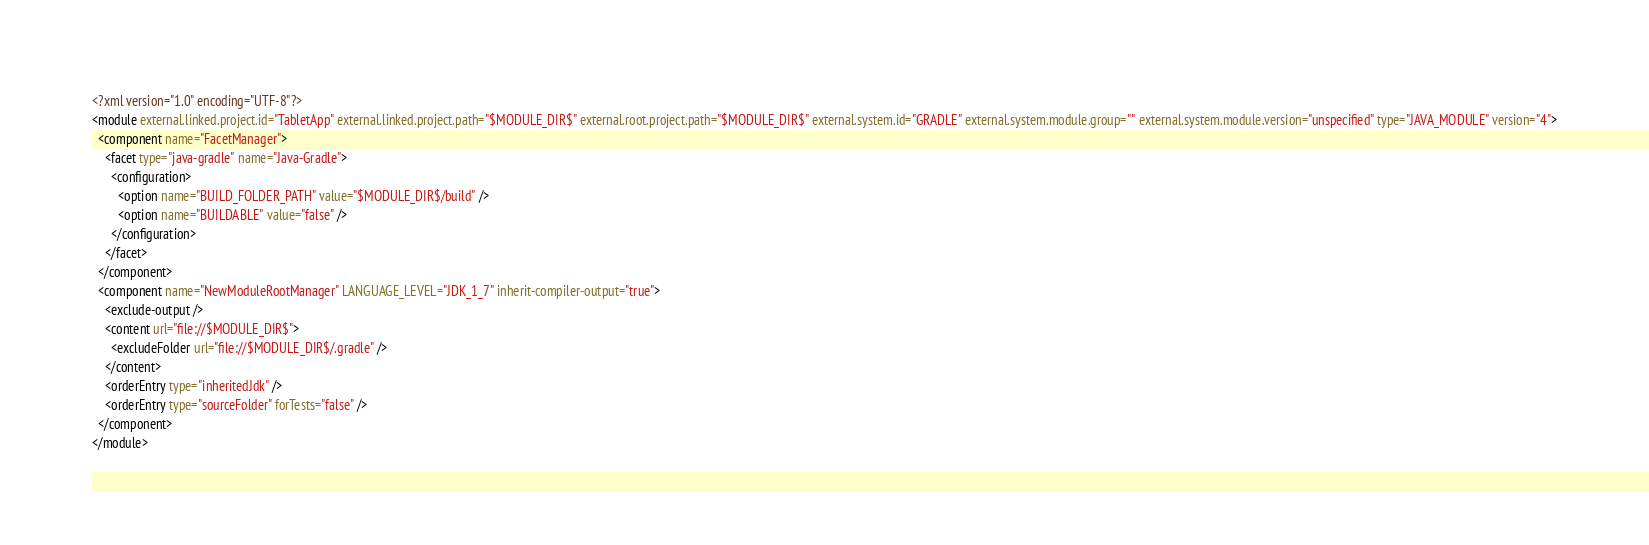<code> <loc_0><loc_0><loc_500><loc_500><_XML_><?xml version="1.0" encoding="UTF-8"?>
<module external.linked.project.id="TabletApp" external.linked.project.path="$MODULE_DIR$" external.root.project.path="$MODULE_DIR$" external.system.id="GRADLE" external.system.module.group="" external.system.module.version="unspecified" type="JAVA_MODULE" version="4">
  <component name="FacetManager">
    <facet type="java-gradle" name="Java-Gradle">
      <configuration>
        <option name="BUILD_FOLDER_PATH" value="$MODULE_DIR$/build" />
        <option name="BUILDABLE" value="false" />
      </configuration>
    </facet>
  </component>
  <component name="NewModuleRootManager" LANGUAGE_LEVEL="JDK_1_7" inherit-compiler-output="true">
    <exclude-output />
    <content url="file://$MODULE_DIR$">
      <excludeFolder url="file://$MODULE_DIR$/.gradle" />
    </content>
    <orderEntry type="inheritedJdk" />
    <orderEntry type="sourceFolder" forTests="false" />
  </component>
</module></code> 